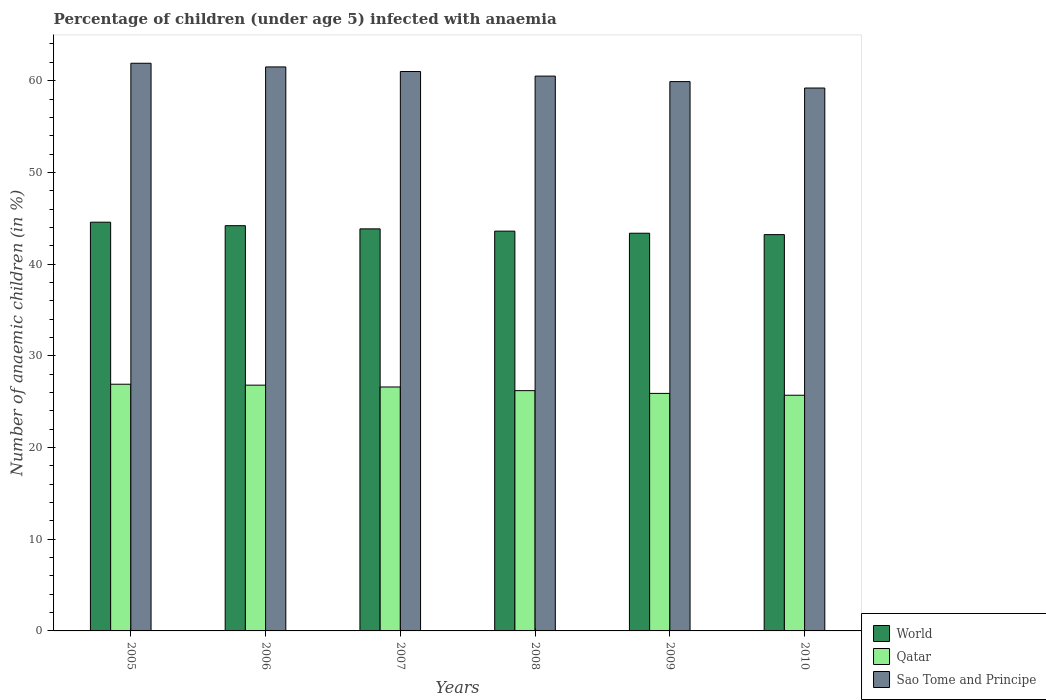How many groups of bars are there?
Your answer should be compact. 6. Are the number of bars per tick equal to the number of legend labels?
Ensure brevity in your answer.  Yes. How many bars are there on the 5th tick from the left?
Make the answer very short. 3. How many bars are there on the 5th tick from the right?
Offer a very short reply. 3. What is the label of the 2nd group of bars from the left?
Give a very brief answer. 2006. In how many cases, is the number of bars for a given year not equal to the number of legend labels?
Offer a very short reply. 0. What is the percentage of children infected with anaemia in in Sao Tome and Principe in 2010?
Your answer should be very brief. 59.2. Across all years, what is the maximum percentage of children infected with anaemia in in Qatar?
Your response must be concise. 26.9. Across all years, what is the minimum percentage of children infected with anaemia in in Qatar?
Offer a terse response. 25.7. What is the total percentage of children infected with anaemia in in World in the graph?
Offer a terse response. 262.77. What is the difference between the percentage of children infected with anaemia in in Sao Tome and Principe in 2006 and that in 2010?
Provide a short and direct response. 2.3. What is the difference between the percentage of children infected with anaemia in in World in 2009 and the percentage of children infected with anaemia in in Qatar in 2006?
Keep it short and to the point. 16.57. What is the average percentage of children infected with anaemia in in World per year?
Make the answer very short. 43.8. In the year 2006, what is the difference between the percentage of children infected with anaemia in in Qatar and percentage of children infected with anaemia in in World?
Offer a very short reply. -17.39. In how many years, is the percentage of children infected with anaemia in in World greater than 44 %?
Give a very brief answer. 2. What is the ratio of the percentage of children infected with anaemia in in Qatar in 2007 to that in 2009?
Make the answer very short. 1.03. What is the difference between the highest and the second highest percentage of children infected with anaemia in in Qatar?
Your response must be concise. 0.1. What is the difference between the highest and the lowest percentage of children infected with anaemia in in World?
Make the answer very short. 1.35. What does the 2nd bar from the left in 2009 represents?
Your answer should be compact. Qatar. What does the 2nd bar from the right in 2010 represents?
Keep it short and to the point. Qatar. Is it the case that in every year, the sum of the percentage of children infected with anaemia in in World and percentage of children infected with anaemia in in Qatar is greater than the percentage of children infected with anaemia in in Sao Tome and Principe?
Keep it short and to the point. Yes. Are all the bars in the graph horizontal?
Keep it short and to the point. No. How many years are there in the graph?
Ensure brevity in your answer.  6. Does the graph contain grids?
Your answer should be very brief. No. Where does the legend appear in the graph?
Give a very brief answer. Bottom right. How are the legend labels stacked?
Your response must be concise. Vertical. What is the title of the graph?
Keep it short and to the point. Percentage of children (under age 5) infected with anaemia. What is the label or title of the X-axis?
Offer a very short reply. Years. What is the label or title of the Y-axis?
Your answer should be compact. Number of anaemic children (in %). What is the Number of anaemic children (in %) of World in 2005?
Your answer should be compact. 44.57. What is the Number of anaemic children (in %) in Qatar in 2005?
Ensure brevity in your answer.  26.9. What is the Number of anaemic children (in %) of Sao Tome and Principe in 2005?
Your response must be concise. 61.9. What is the Number of anaemic children (in %) in World in 2006?
Your answer should be very brief. 44.19. What is the Number of anaemic children (in %) of Qatar in 2006?
Your answer should be compact. 26.8. What is the Number of anaemic children (in %) in Sao Tome and Principe in 2006?
Make the answer very short. 61.5. What is the Number of anaemic children (in %) in World in 2007?
Your response must be concise. 43.84. What is the Number of anaemic children (in %) in Qatar in 2007?
Your answer should be very brief. 26.6. What is the Number of anaemic children (in %) of Sao Tome and Principe in 2007?
Your answer should be compact. 61. What is the Number of anaemic children (in %) in World in 2008?
Provide a short and direct response. 43.59. What is the Number of anaemic children (in %) of Qatar in 2008?
Provide a short and direct response. 26.2. What is the Number of anaemic children (in %) of Sao Tome and Principe in 2008?
Your answer should be very brief. 60.5. What is the Number of anaemic children (in %) of World in 2009?
Give a very brief answer. 43.37. What is the Number of anaemic children (in %) of Qatar in 2009?
Your response must be concise. 25.9. What is the Number of anaemic children (in %) in Sao Tome and Principe in 2009?
Provide a short and direct response. 59.9. What is the Number of anaemic children (in %) in World in 2010?
Make the answer very short. 43.21. What is the Number of anaemic children (in %) in Qatar in 2010?
Keep it short and to the point. 25.7. What is the Number of anaemic children (in %) in Sao Tome and Principe in 2010?
Provide a succinct answer. 59.2. Across all years, what is the maximum Number of anaemic children (in %) of World?
Keep it short and to the point. 44.57. Across all years, what is the maximum Number of anaemic children (in %) in Qatar?
Ensure brevity in your answer.  26.9. Across all years, what is the maximum Number of anaemic children (in %) of Sao Tome and Principe?
Your answer should be very brief. 61.9. Across all years, what is the minimum Number of anaemic children (in %) of World?
Your answer should be very brief. 43.21. Across all years, what is the minimum Number of anaemic children (in %) in Qatar?
Offer a very short reply. 25.7. Across all years, what is the minimum Number of anaemic children (in %) in Sao Tome and Principe?
Ensure brevity in your answer.  59.2. What is the total Number of anaemic children (in %) in World in the graph?
Offer a very short reply. 262.77. What is the total Number of anaemic children (in %) of Qatar in the graph?
Your answer should be compact. 158.1. What is the total Number of anaemic children (in %) in Sao Tome and Principe in the graph?
Make the answer very short. 364. What is the difference between the Number of anaemic children (in %) of World in 2005 and that in 2006?
Make the answer very short. 0.38. What is the difference between the Number of anaemic children (in %) of Qatar in 2005 and that in 2006?
Your answer should be compact. 0.1. What is the difference between the Number of anaemic children (in %) in Sao Tome and Principe in 2005 and that in 2006?
Make the answer very short. 0.4. What is the difference between the Number of anaemic children (in %) of World in 2005 and that in 2007?
Your answer should be very brief. 0.73. What is the difference between the Number of anaemic children (in %) in Qatar in 2005 and that in 2007?
Ensure brevity in your answer.  0.3. What is the difference between the Number of anaemic children (in %) of Sao Tome and Principe in 2005 and that in 2007?
Your answer should be compact. 0.9. What is the difference between the Number of anaemic children (in %) of World in 2005 and that in 2008?
Your response must be concise. 0.97. What is the difference between the Number of anaemic children (in %) of Qatar in 2005 and that in 2008?
Provide a short and direct response. 0.7. What is the difference between the Number of anaemic children (in %) in Sao Tome and Principe in 2005 and that in 2008?
Your response must be concise. 1.4. What is the difference between the Number of anaemic children (in %) of World in 2005 and that in 2009?
Your answer should be compact. 1.2. What is the difference between the Number of anaemic children (in %) of World in 2005 and that in 2010?
Keep it short and to the point. 1.35. What is the difference between the Number of anaemic children (in %) in Qatar in 2005 and that in 2010?
Provide a short and direct response. 1.2. What is the difference between the Number of anaemic children (in %) in World in 2006 and that in 2007?
Your response must be concise. 0.35. What is the difference between the Number of anaemic children (in %) of World in 2006 and that in 2008?
Provide a short and direct response. 0.59. What is the difference between the Number of anaemic children (in %) in Qatar in 2006 and that in 2008?
Offer a very short reply. 0.6. What is the difference between the Number of anaemic children (in %) in World in 2006 and that in 2009?
Keep it short and to the point. 0.82. What is the difference between the Number of anaemic children (in %) of World in 2006 and that in 2010?
Give a very brief answer. 0.97. What is the difference between the Number of anaemic children (in %) of World in 2007 and that in 2008?
Keep it short and to the point. 0.25. What is the difference between the Number of anaemic children (in %) in Sao Tome and Principe in 2007 and that in 2008?
Your answer should be compact. 0.5. What is the difference between the Number of anaemic children (in %) in World in 2007 and that in 2009?
Provide a short and direct response. 0.48. What is the difference between the Number of anaemic children (in %) of World in 2007 and that in 2010?
Offer a terse response. 0.63. What is the difference between the Number of anaemic children (in %) in World in 2008 and that in 2009?
Keep it short and to the point. 0.23. What is the difference between the Number of anaemic children (in %) of Qatar in 2008 and that in 2009?
Offer a terse response. 0.3. What is the difference between the Number of anaemic children (in %) in Sao Tome and Principe in 2008 and that in 2009?
Offer a very short reply. 0.6. What is the difference between the Number of anaemic children (in %) of World in 2008 and that in 2010?
Offer a very short reply. 0.38. What is the difference between the Number of anaemic children (in %) in Sao Tome and Principe in 2008 and that in 2010?
Give a very brief answer. 1.3. What is the difference between the Number of anaemic children (in %) in World in 2009 and that in 2010?
Give a very brief answer. 0.15. What is the difference between the Number of anaemic children (in %) of Qatar in 2009 and that in 2010?
Your answer should be very brief. 0.2. What is the difference between the Number of anaemic children (in %) of Sao Tome and Principe in 2009 and that in 2010?
Offer a terse response. 0.7. What is the difference between the Number of anaemic children (in %) of World in 2005 and the Number of anaemic children (in %) of Qatar in 2006?
Ensure brevity in your answer.  17.77. What is the difference between the Number of anaemic children (in %) in World in 2005 and the Number of anaemic children (in %) in Sao Tome and Principe in 2006?
Provide a short and direct response. -16.93. What is the difference between the Number of anaemic children (in %) in Qatar in 2005 and the Number of anaemic children (in %) in Sao Tome and Principe in 2006?
Offer a terse response. -34.6. What is the difference between the Number of anaemic children (in %) in World in 2005 and the Number of anaemic children (in %) in Qatar in 2007?
Provide a succinct answer. 17.97. What is the difference between the Number of anaemic children (in %) in World in 2005 and the Number of anaemic children (in %) in Sao Tome and Principe in 2007?
Give a very brief answer. -16.43. What is the difference between the Number of anaemic children (in %) of Qatar in 2005 and the Number of anaemic children (in %) of Sao Tome and Principe in 2007?
Provide a succinct answer. -34.1. What is the difference between the Number of anaemic children (in %) of World in 2005 and the Number of anaemic children (in %) of Qatar in 2008?
Your answer should be very brief. 18.37. What is the difference between the Number of anaemic children (in %) in World in 2005 and the Number of anaemic children (in %) in Sao Tome and Principe in 2008?
Provide a short and direct response. -15.93. What is the difference between the Number of anaemic children (in %) in Qatar in 2005 and the Number of anaemic children (in %) in Sao Tome and Principe in 2008?
Provide a succinct answer. -33.6. What is the difference between the Number of anaemic children (in %) of World in 2005 and the Number of anaemic children (in %) of Qatar in 2009?
Give a very brief answer. 18.67. What is the difference between the Number of anaemic children (in %) in World in 2005 and the Number of anaemic children (in %) in Sao Tome and Principe in 2009?
Your response must be concise. -15.33. What is the difference between the Number of anaemic children (in %) of Qatar in 2005 and the Number of anaemic children (in %) of Sao Tome and Principe in 2009?
Offer a terse response. -33. What is the difference between the Number of anaemic children (in %) in World in 2005 and the Number of anaemic children (in %) in Qatar in 2010?
Your response must be concise. 18.87. What is the difference between the Number of anaemic children (in %) of World in 2005 and the Number of anaemic children (in %) of Sao Tome and Principe in 2010?
Ensure brevity in your answer.  -14.63. What is the difference between the Number of anaemic children (in %) of Qatar in 2005 and the Number of anaemic children (in %) of Sao Tome and Principe in 2010?
Ensure brevity in your answer.  -32.3. What is the difference between the Number of anaemic children (in %) of World in 2006 and the Number of anaemic children (in %) of Qatar in 2007?
Your response must be concise. 17.59. What is the difference between the Number of anaemic children (in %) of World in 2006 and the Number of anaemic children (in %) of Sao Tome and Principe in 2007?
Offer a very short reply. -16.81. What is the difference between the Number of anaemic children (in %) in Qatar in 2006 and the Number of anaemic children (in %) in Sao Tome and Principe in 2007?
Your response must be concise. -34.2. What is the difference between the Number of anaemic children (in %) of World in 2006 and the Number of anaemic children (in %) of Qatar in 2008?
Your response must be concise. 17.99. What is the difference between the Number of anaemic children (in %) in World in 2006 and the Number of anaemic children (in %) in Sao Tome and Principe in 2008?
Your answer should be very brief. -16.31. What is the difference between the Number of anaemic children (in %) of Qatar in 2006 and the Number of anaemic children (in %) of Sao Tome and Principe in 2008?
Offer a very short reply. -33.7. What is the difference between the Number of anaemic children (in %) in World in 2006 and the Number of anaemic children (in %) in Qatar in 2009?
Offer a terse response. 18.29. What is the difference between the Number of anaemic children (in %) in World in 2006 and the Number of anaemic children (in %) in Sao Tome and Principe in 2009?
Provide a succinct answer. -15.71. What is the difference between the Number of anaemic children (in %) in Qatar in 2006 and the Number of anaemic children (in %) in Sao Tome and Principe in 2009?
Offer a terse response. -33.1. What is the difference between the Number of anaemic children (in %) in World in 2006 and the Number of anaemic children (in %) in Qatar in 2010?
Keep it short and to the point. 18.49. What is the difference between the Number of anaemic children (in %) in World in 2006 and the Number of anaemic children (in %) in Sao Tome and Principe in 2010?
Make the answer very short. -15.01. What is the difference between the Number of anaemic children (in %) of Qatar in 2006 and the Number of anaemic children (in %) of Sao Tome and Principe in 2010?
Make the answer very short. -32.4. What is the difference between the Number of anaemic children (in %) in World in 2007 and the Number of anaemic children (in %) in Qatar in 2008?
Make the answer very short. 17.64. What is the difference between the Number of anaemic children (in %) of World in 2007 and the Number of anaemic children (in %) of Sao Tome and Principe in 2008?
Ensure brevity in your answer.  -16.66. What is the difference between the Number of anaemic children (in %) in Qatar in 2007 and the Number of anaemic children (in %) in Sao Tome and Principe in 2008?
Make the answer very short. -33.9. What is the difference between the Number of anaemic children (in %) of World in 2007 and the Number of anaemic children (in %) of Qatar in 2009?
Your answer should be very brief. 17.94. What is the difference between the Number of anaemic children (in %) in World in 2007 and the Number of anaemic children (in %) in Sao Tome and Principe in 2009?
Give a very brief answer. -16.06. What is the difference between the Number of anaemic children (in %) in Qatar in 2007 and the Number of anaemic children (in %) in Sao Tome and Principe in 2009?
Provide a succinct answer. -33.3. What is the difference between the Number of anaemic children (in %) of World in 2007 and the Number of anaemic children (in %) of Qatar in 2010?
Your answer should be compact. 18.14. What is the difference between the Number of anaemic children (in %) in World in 2007 and the Number of anaemic children (in %) in Sao Tome and Principe in 2010?
Offer a very short reply. -15.36. What is the difference between the Number of anaemic children (in %) in Qatar in 2007 and the Number of anaemic children (in %) in Sao Tome and Principe in 2010?
Provide a succinct answer. -32.6. What is the difference between the Number of anaemic children (in %) in World in 2008 and the Number of anaemic children (in %) in Qatar in 2009?
Offer a very short reply. 17.69. What is the difference between the Number of anaemic children (in %) of World in 2008 and the Number of anaemic children (in %) of Sao Tome and Principe in 2009?
Provide a succinct answer. -16.31. What is the difference between the Number of anaemic children (in %) of Qatar in 2008 and the Number of anaemic children (in %) of Sao Tome and Principe in 2009?
Provide a short and direct response. -33.7. What is the difference between the Number of anaemic children (in %) in World in 2008 and the Number of anaemic children (in %) in Qatar in 2010?
Your answer should be compact. 17.89. What is the difference between the Number of anaemic children (in %) in World in 2008 and the Number of anaemic children (in %) in Sao Tome and Principe in 2010?
Give a very brief answer. -15.61. What is the difference between the Number of anaemic children (in %) of Qatar in 2008 and the Number of anaemic children (in %) of Sao Tome and Principe in 2010?
Provide a short and direct response. -33. What is the difference between the Number of anaemic children (in %) of World in 2009 and the Number of anaemic children (in %) of Qatar in 2010?
Keep it short and to the point. 17.67. What is the difference between the Number of anaemic children (in %) in World in 2009 and the Number of anaemic children (in %) in Sao Tome and Principe in 2010?
Your answer should be compact. -15.83. What is the difference between the Number of anaemic children (in %) in Qatar in 2009 and the Number of anaemic children (in %) in Sao Tome and Principe in 2010?
Ensure brevity in your answer.  -33.3. What is the average Number of anaemic children (in %) in World per year?
Your answer should be compact. 43.8. What is the average Number of anaemic children (in %) of Qatar per year?
Your answer should be compact. 26.35. What is the average Number of anaemic children (in %) of Sao Tome and Principe per year?
Your answer should be compact. 60.67. In the year 2005, what is the difference between the Number of anaemic children (in %) in World and Number of anaemic children (in %) in Qatar?
Provide a short and direct response. 17.67. In the year 2005, what is the difference between the Number of anaemic children (in %) of World and Number of anaemic children (in %) of Sao Tome and Principe?
Keep it short and to the point. -17.33. In the year 2005, what is the difference between the Number of anaemic children (in %) in Qatar and Number of anaemic children (in %) in Sao Tome and Principe?
Ensure brevity in your answer.  -35. In the year 2006, what is the difference between the Number of anaemic children (in %) of World and Number of anaemic children (in %) of Qatar?
Provide a succinct answer. 17.39. In the year 2006, what is the difference between the Number of anaemic children (in %) in World and Number of anaemic children (in %) in Sao Tome and Principe?
Ensure brevity in your answer.  -17.31. In the year 2006, what is the difference between the Number of anaemic children (in %) of Qatar and Number of anaemic children (in %) of Sao Tome and Principe?
Provide a succinct answer. -34.7. In the year 2007, what is the difference between the Number of anaemic children (in %) of World and Number of anaemic children (in %) of Qatar?
Your answer should be very brief. 17.24. In the year 2007, what is the difference between the Number of anaemic children (in %) in World and Number of anaemic children (in %) in Sao Tome and Principe?
Your answer should be compact. -17.16. In the year 2007, what is the difference between the Number of anaemic children (in %) in Qatar and Number of anaemic children (in %) in Sao Tome and Principe?
Offer a very short reply. -34.4. In the year 2008, what is the difference between the Number of anaemic children (in %) in World and Number of anaemic children (in %) in Qatar?
Make the answer very short. 17.39. In the year 2008, what is the difference between the Number of anaemic children (in %) of World and Number of anaemic children (in %) of Sao Tome and Principe?
Your response must be concise. -16.91. In the year 2008, what is the difference between the Number of anaemic children (in %) in Qatar and Number of anaemic children (in %) in Sao Tome and Principe?
Keep it short and to the point. -34.3. In the year 2009, what is the difference between the Number of anaemic children (in %) in World and Number of anaemic children (in %) in Qatar?
Your answer should be compact. 17.47. In the year 2009, what is the difference between the Number of anaemic children (in %) of World and Number of anaemic children (in %) of Sao Tome and Principe?
Provide a short and direct response. -16.53. In the year 2009, what is the difference between the Number of anaemic children (in %) of Qatar and Number of anaemic children (in %) of Sao Tome and Principe?
Your response must be concise. -34. In the year 2010, what is the difference between the Number of anaemic children (in %) in World and Number of anaemic children (in %) in Qatar?
Ensure brevity in your answer.  17.51. In the year 2010, what is the difference between the Number of anaemic children (in %) of World and Number of anaemic children (in %) of Sao Tome and Principe?
Offer a terse response. -15.99. In the year 2010, what is the difference between the Number of anaemic children (in %) in Qatar and Number of anaemic children (in %) in Sao Tome and Principe?
Keep it short and to the point. -33.5. What is the ratio of the Number of anaemic children (in %) of World in 2005 to that in 2006?
Provide a short and direct response. 1.01. What is the ratio of the Number of anaemic children (in %) in Qatar in 2005 to that in 2006?
Your answer should be very brief. 1. What is the ratio of the Number of anaemic children (in %) of World in 2005 to that in 2007?
Your response must be concise. 1.02. What is the ratio of the Number of anaemic children (in %) of Qatar in 2005 to that in 2007?
Keep it short and to the point. 1.01. What is the ratio of the Number of anaemic children (in %) of Sao Tome and Principe in 2005 to that in 2007?
Give a very brief answer. 1.01. What is the ratio of the Number of anaemic children (in %) of World in 2005 to that in 2008?
Offer a very short reply. 1.02. What is the ratio of the Number of anaemic children (in %) in Qatar in 2005 to that in 2008?
Your response must be concise. 1.03. What is the ratio of the Number of anaemic children (in %) of Sao Tome and Principe in 2005 to that in 2008?
Offer a terse response. 1.02. What is the ratio of the Number of anaemic children (in %) in World in 2005 to that in 2009?
Give a very brief answer. 1.03. What is the ratio of the Number of anaemic children (in %) of Qatar in 2005 to that in 2009?
Offer a terse response. 1.04. What is the ratio of the Number of anaemic children (in %) of Sao Tome and Principe in 2005 to that in 2009?
Your response must be concise. 1.03. What is the ratio of the Number of anaemic children (in %) of World in 2005 to that in 2010?
Ensure brevity in your answer.  1.03. What is the ratio of the Number of anaemic children (in %) in Qatar in 2005 to that in 2010?
Offer a terse response. 1.05. What is the ratio of the Number of anaemic children (in %) in Sao Tome and Principe in 2005 to that in 2010?
Your response must be concise. 1.05. What is the ratio of the Number of anaemic children (in %) in World in 2006 to that in 2007?
Provide a succinct answer. 1.01. What is the ratio of the Number of anaemic children (in %) in Qatar in 2006 to that in 2007?
Provide a short and direct response. 1.01. What is the ratio of the Number of anaemic children (in %) in Sao Tome and Principe in 2006 to that in 2007?
Give a very brief answer. 1.01. What is the ratio of the Number of anaemic children (in %) of World in 2006 to that in 2008?
Ensure brevity in your answer.  1.01. What is the ratio of the Number of anaemic children (in %) of Qatar in 2006 to that in 2008?
Offer a terse response. 1.02. What is the ratio of the Number of anaemic children (in %) of Sao Tome and Principe in 2006 to that in 2008?
Your response must be concise. 1.02. What is the ratio of the Number of anaemic children (in %) of World in 2006 to that in 2009?
Provide a short and direct response. 1.02. What is the ratio of the Number of anaemic children (in %) in Qatar in 2006 to that in 2009?
Ensure brevity in your answer.  1.03. What is the ratio of the Number of anaemic children (in %) in Sao Tome and Principe in 2006 to that in 2009?
Your answer should be very brief. 1.03. What is the ratio of the Number of anaemic children (in %) in World in 2006 to that in 2010?
Your response must be concise. 1.02. What is the ratio of the Number of anaemic children (in %) in Qatar in 2006 to that in 2010?
Offer a very short reply. 1.04. What is the ratio of the Number of anaemic children (in %) of Sao Tome and Principe in 2006 to that in 2010?
Keep it short and to the point. 1.04. What is the ratio of the Number of anaemic children (in %) in World in 2007 to that in 2008?
Offer a terse response. 1.01. What is the ratio of the Number of anaemic children (in %) of Qatar in 2007 to that in 2008?
Keep it short and to the point. 1.02. What is the ratio of the Number of anaemic children (in %) of Sao Tome and Principe in 2007 to that in 2008?
Your answer should be compact. 1.01. What is the ratio of the Number of anaemic children (in %) in Sao Tome and Principe in 2007 to that in 2009?
Provide a short and direct response. 1.02. What is the ratio of the Number of anaemic children (in %) of World in 2007 to that in 2010?
Your response must be concise. 1.01. What is the ratio of the Number of anaemic children (in %) of Qatar in 2007 to that in 2010?
Make the answer very short. 1.03. What is the ratio of the Number of anaemic children (in %) of Sao Tome and Principe in 2007 to that in 2010?
Provide a short and direct response. 1.03. What is the ratio of the Number of anaemic children (in %) in Qatar in 2008 to that in 2009?
Make the answer very short. 1.01. What is the ratio of the Number of anaemic children (in %) of World in 2008 to that in 2010?
Provide a succinct answer. 1.01. What is the ratio of the Number of anaemic children (in %) in Qatar in 2008 to that in 2010?
Your answer should be compact. 1.02. What is the ratio of the Number of anaemic children (in %) of Sao Tome and Principe in 2008 to that in 2010?
Your answer should be very brief. 1.02. What is the ratio of the Number of anaemic children (in %) of Sao Tome and Principe in 2009 to that in 2010?
Offer a terse response. 1.01. What is the difference between the highest and the second highest Number of anaemic children (in %) in World?
Your answer should be very brief. 0.38. What is the difference between the highest and the second highest Number of anaemic children (in %) in Qatar?
Keep it short and to the point. 0.1. What is the difference between the highest and the second highest Number of anaemic children (in %) of Sao Tome and Principe?
Provide a succinct answer. 0.4. What is the difference between the highest and the lowest Number of anaemic children (in %) of World?
Your answer should be very brief. 1.35. What is the difference between the highest and the lowest Number of anaemic children (in %) in Qatar?
Give a very brief answer. 1.2. What is the difference between the highest and the lowest Number of anaemic children (in %) in Sao Tome and Principe?
Offer a very short reply. 2.7. 